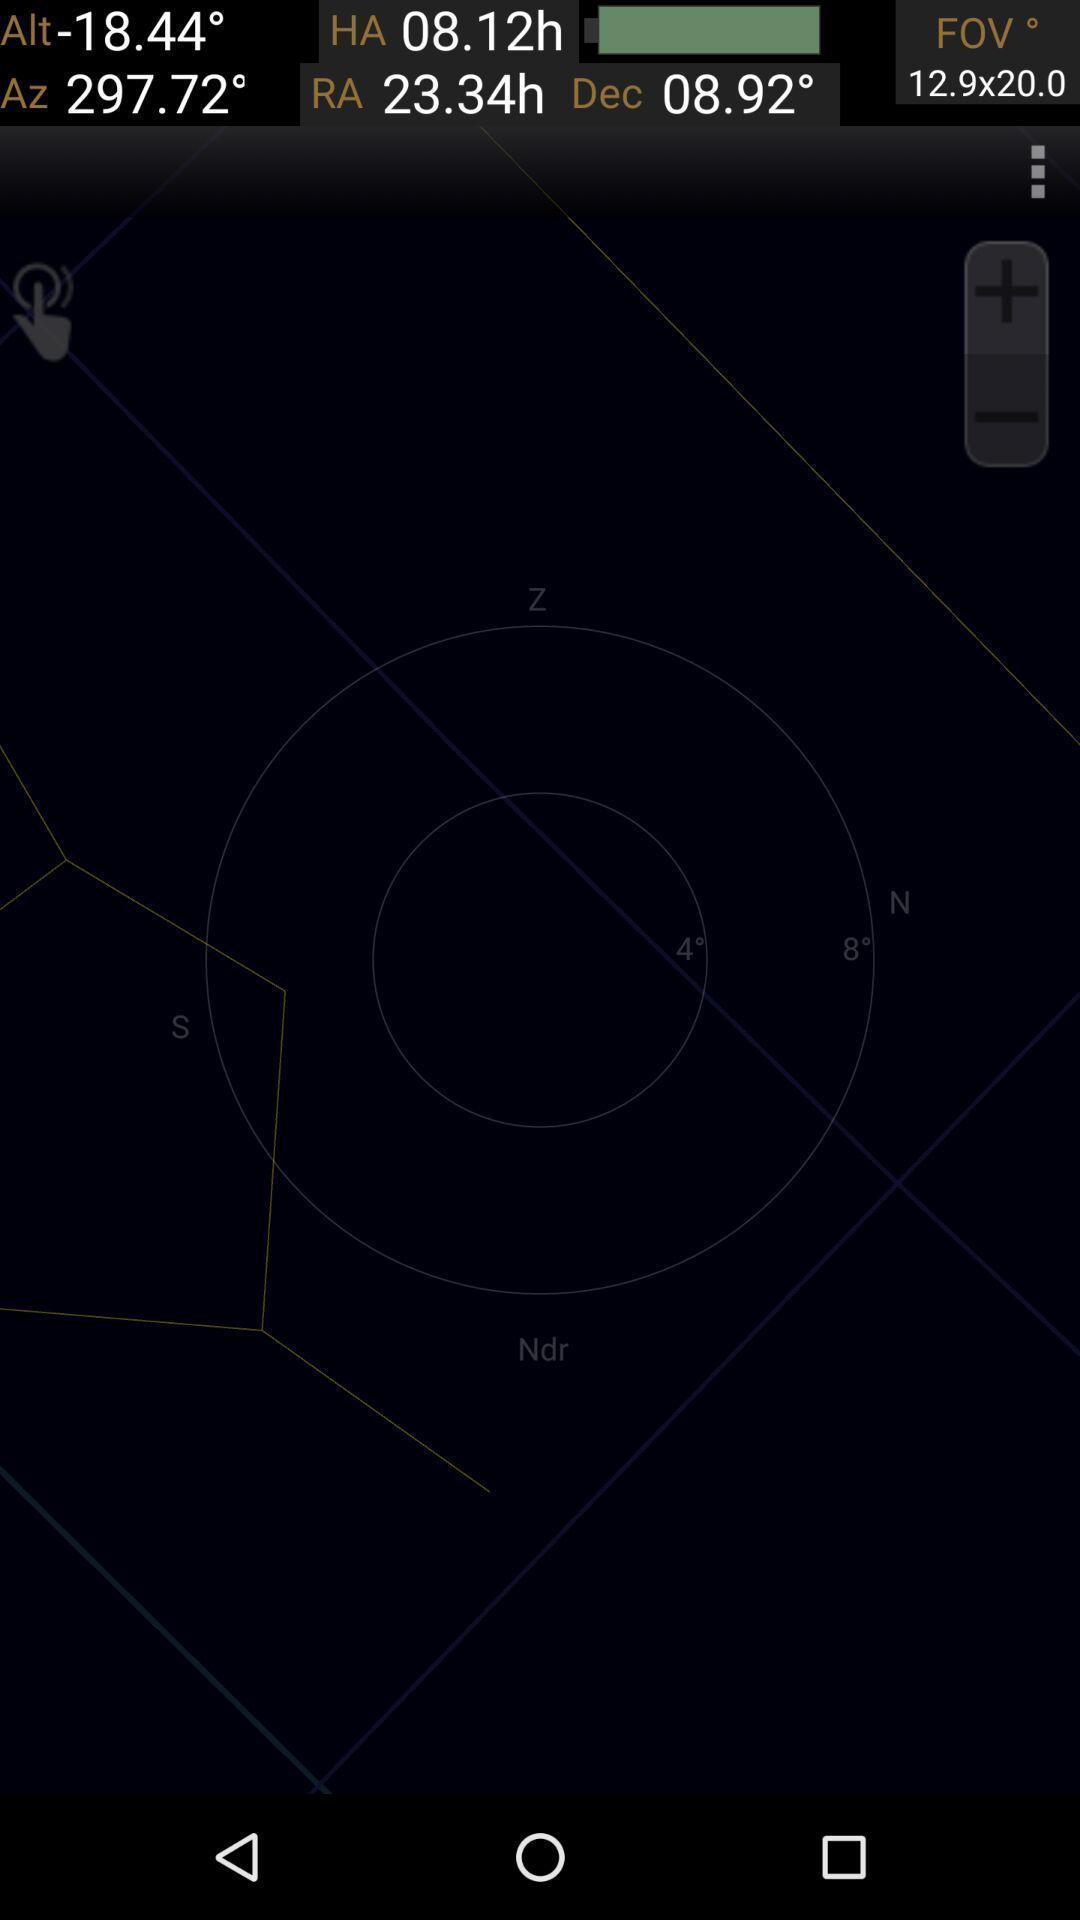Tell me what you see in this picture. Screen displaying page. 